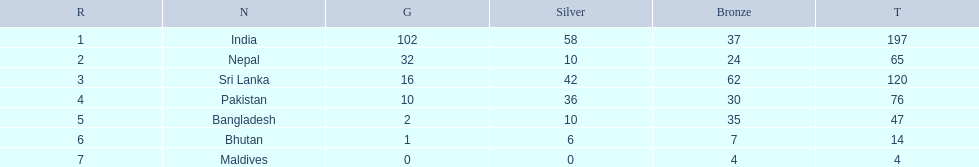What are all the countries listed in the table? India, Nepal, Sri Lanka, Pakistan, Bangladesh, Bhutan, Maldives. Which of these is not india? Nepal, Sri Lanka, Pakistan, Bangladesh, Bhutan, Maldives. Of these, which is first? Nepal. 